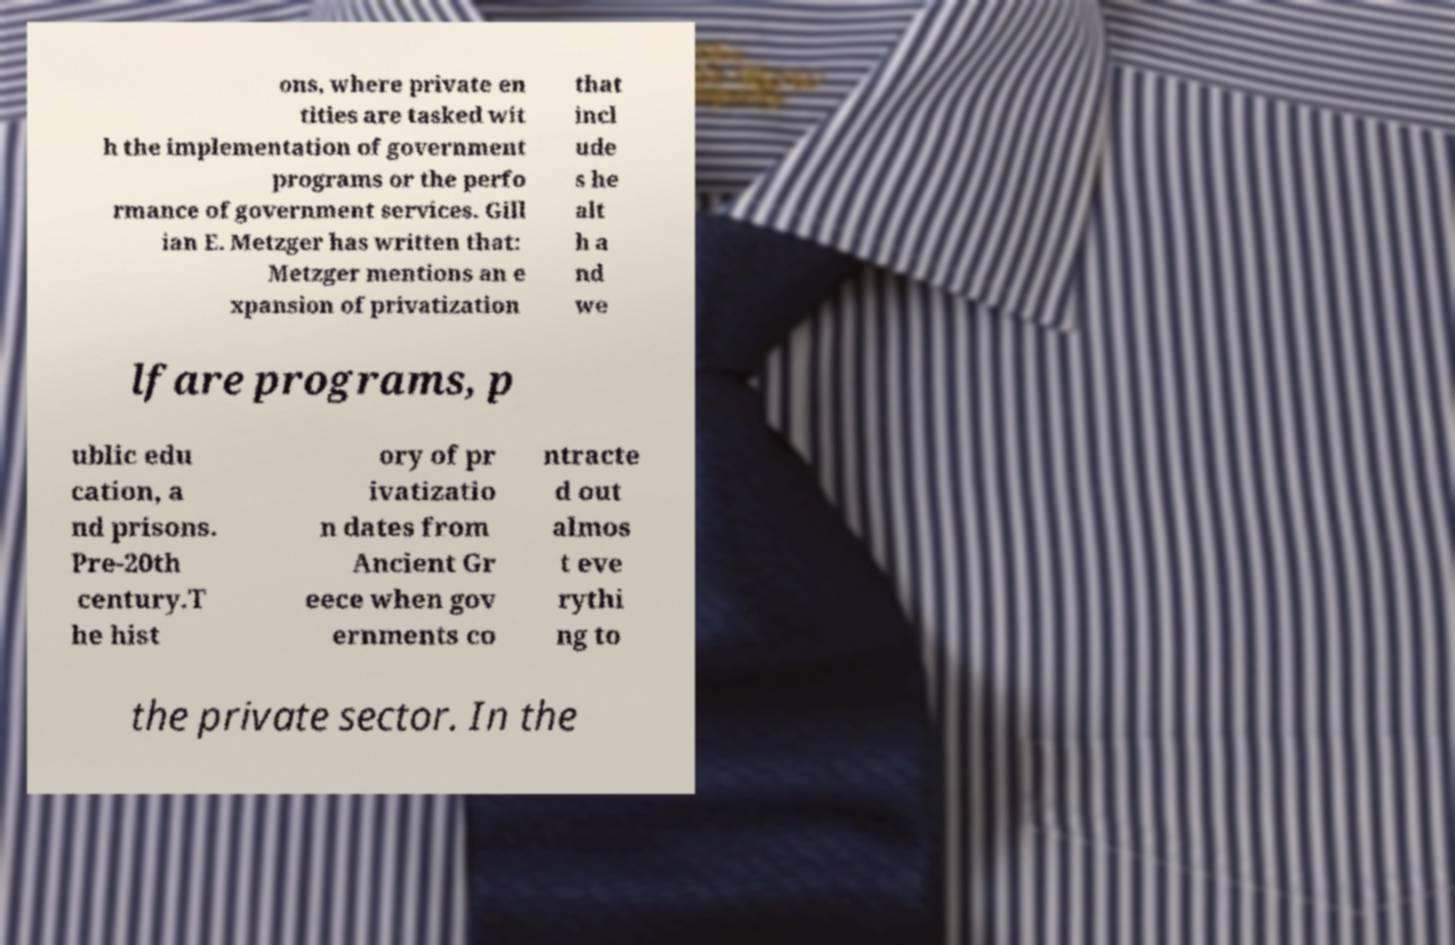I need the written content from this picture converted into text. Can you do that? ons, where private en tities are tasked wit h the implementation of government programs or the perfo rmance of government services. Gill ian E. Metzger has written that: Metzger mentions an e xpansion of privatization that incl ude s he alt h a nd we lfare programs, p ublic edu cation, a nd prisons. Pre-20th century.T he hist ory of pr ivatizatio n dates from Ancient Gr eece when gov ernments co ntracte d out almos t eve rythi ng to the private sector. In the 